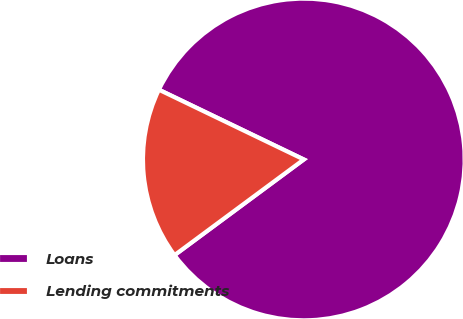<chart> <loc_0><loc_0><loc_500><loc_500><pie_chart><fcel>Loans<fcel>Lending commitments<nl><fcel>82.72%<fcel>17.28%<nl></chart> 